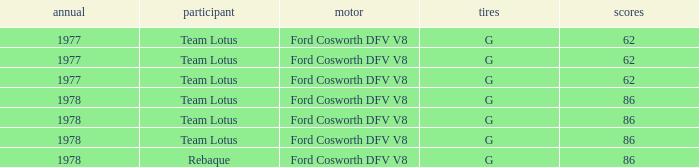What is the Motor that has a Focuses bigger than 62, and a Participant of rebaque? Ford Cosworth DFV V8. 